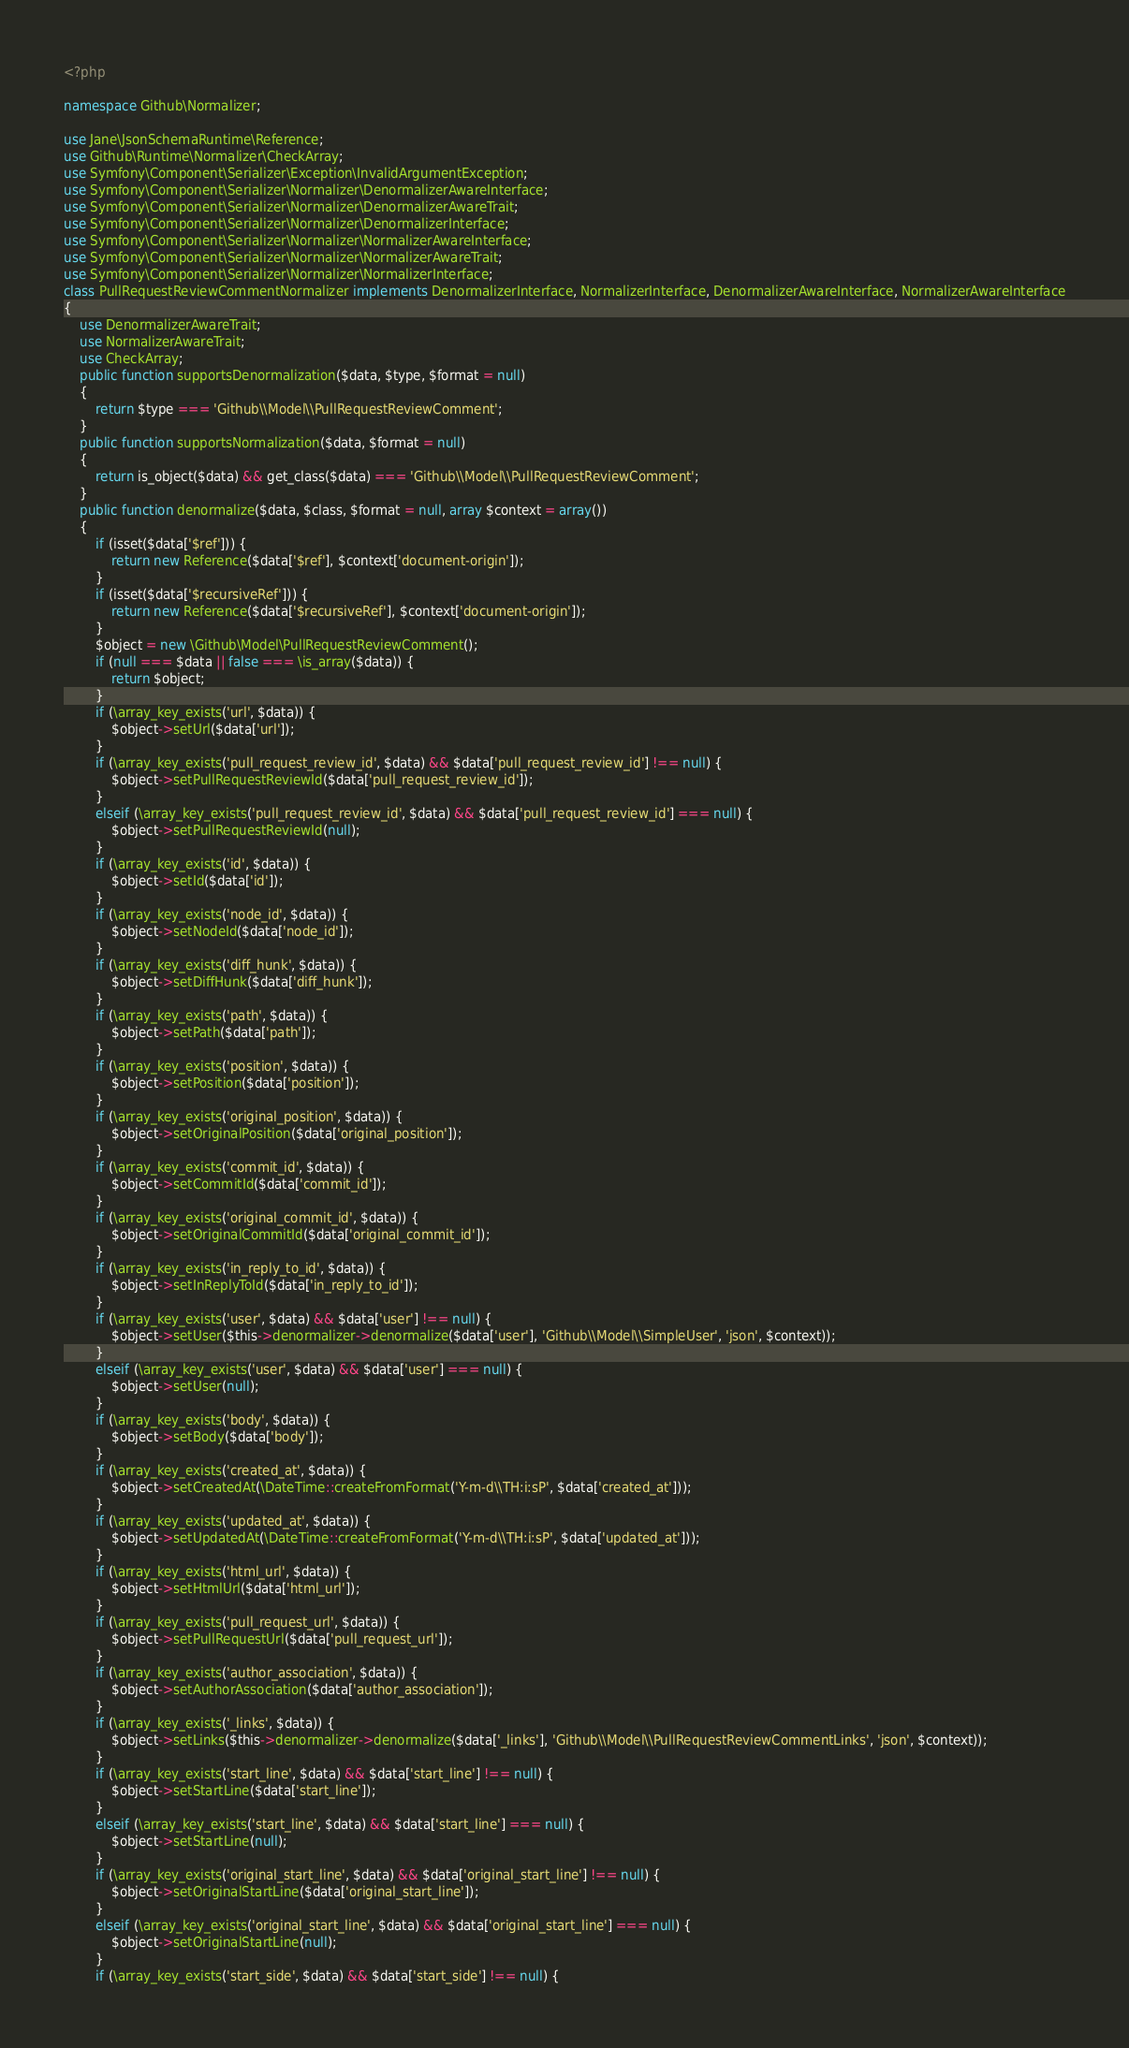<code> <loc_0><loc_0><loc_500><loc_500><_PHP_><?php

namespace Github\Normalizer;

use Jane\JsonSchemaRuntime\Reference;
use Github\Runtime\Normalizer\CheckArray;
use Symfony\Component\Serializer\Exception\InvalidArgumentException;
use Symfony\Component\Serializer\Normalizer\DenormalizerAwareInterface;
use Symfony\Component\Serializer\Normalizer\DenormalizerAwareTrait;
use Symfony\Component\Serializer\Normalizer\DenormalizerInterface;
use Symfony\Component\Serializer\Normalizer\NormalizerAwareInterface;
use Symfony\Component\Serializer\Normalizer\NormalizerAwareTrait;
use Symfony\Component\Serializer\Normalizer\NormalizerInterface;
class PullRequestReviewCommentNormalizer implements DenormalizerInterface, NormalizerInterface, DenormalizerAwareInterface, NormalizerAwareInterface
{
    use DenormalizerAwareTrait;
    use NormalizerAwareTrait;
    use CheckArray;
    public function supportsDenormalization($data, $type, $format = null)
    {
        return $type === 'Github\\Model\\PullRequestReviewComment';
    }
    public function supportsNormalization($data, $format = null)
    {
        return is_object($data) && get_class($data) === 'Github\\Model\\PullRequestReviewComment';
    }
    public function denormalize($data, $class, $format = null, array $context = array())
    {
        if (isset($data['$ref'])) {
            return new Reference($data['$ref'], $context['document-origin']);
        }
        if (isset($data['$recursiveRef'])) {
            return new Reference($data['$recursiveRef'], $context['document-origin']);
        }
        $object = new \Github\Model\PullRequestReviewComment();
        if (null === $data || false === \is_array($data)) {
            return $object;
        }
        if (\array_key_exists('url', $data)) {
            $object->setUrl($data['url']);
        }
        if (\array_key_exists('pull_request_review_id', $data) && $data['pull_request_review_id'] !== null) {
            $object->setPullRequestReviewId($data['pull_request_review_id']);
        }
        elseif (\array_key_exists('pull_request_review_id', $data) && $data['pull_request_review_id'] === null) {
            $object->setPullRequestReviewId(null);
        }
        if (\array_key_exists('id', $data)) {
            $object->setId($data['id']);
        }
        if (\array_key_exists('node_id', $data)) {
            $object->setNodeId($data['node_id']);
        }
        if (\array_key_exists('diff_hunk', $data)) {
            $object->setDiffHunk($data['diff_hunk']);
        }
        if (\array_key_exists('path', $data)) {
            $object->setPath($data['path']);
        }
        if (\array_key_exists('position', $data)) {
            $object->setPosition($data['position']);
        }
        if (\array_key_exists('original_position', $data)) {
            $object->setOriginalPosition($data['original_position']);
        }
        if (\array_key_exists('commit_id', $data)) {
            $object->setCommitId($data['commit_id']);
        }
        if (\array_key_exists('original_commit_id', $data)) {
            $object->setOriginalCommitId($data['original_commit_id']);
        }
        if (\array_key_exists('in_reply_to_id', $data)) {
            $object->setInReplyToId($data['in_reply_to_id']);
        }
        if (\array_key_exists('user', $data) && $data['user'] !== null) {
            $object->setUser($this->denormalizer->denormalize($data['user'], 'Github\\Model\\SimpleUser', 'json', $context));
        }
        elseif (\array_key_exists('user', $data) && $data['user'] === null) {
            $object->setUser(null);
        }
        if (\array_key_exists('body', $data)) {
            $object->setBody($data['body']);
        }
        if (\array_key_exists('created_at', $data)) {
            $object->setCreatedAt(\DateTime::createFromFormat('Y-m-d\\TH:i:sP', $data['created_at']));
        }
        if (\array_key_exists('updated_at', $data)) {
            $object->setUpdatedAt(\DateTime::createFromFormat('Y-m-d\\TH:i:sP', $data['updated_at']));
        }
        if (\array_key_exists('html_url', $data)) {
            $object->setHtmlUrl($data['html_url']);
        }
        if (\array_key_exists('pull_request_url', $data)) {
            $object->setPullRequestUrl($data['pull_request_url']);
        }
        if (\array_key_exists('author_association', $data)) {
            $object->setAuthorAssociation($data['author_association']);
        }
        if (\array_key_exists('_links', $data)) {
            $object->setLinks($this->denormalizer->denormalize($data['_links'], 'Github\\Model\\PullRequestReviewCommentLinks', 'json', $context));
        }
        if (\array_key_exists('start_line', $data) && $data['start_line'] !== null) {
            $object->setStartLine($data['start_line']);
        }
        elseif (\array_key_exists('start_line', $data) && $data['start_line'] === null) {
            $object->setStartLine(null);
        }
        if (\array_key_exists('original_start_line', $data) && $data['original_start_line'] !== null) {
            $object->setOriginalStartLine($data['original_start_line']);
        }
        elseif (\array_key_exists('original_start_line', $data) && $data['original_start_line'] === null) {
            $object->setOriginalStartLine(null);
        }
        if (\array_key_exists('start_side', $data) && $data['start_side'] !== null) {</code> 